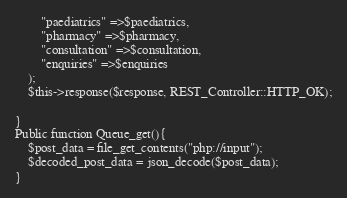Convert code to text. <code><loc_0><loc_0><loc_500><loc_500><_PHP_>        "paediatrics" =>$paediatrics,
        "pharmacy" =>$pharmacy,
        "consultation" =>$consultation,
        "enquiries" =>$enquiries
    );
    $this->response($response, REST_Controller::HTTP_OK);

}
Public function Queue_get(){
    $post_data = file_get_contents("php://input");
    $decoded_post_data = json_decode($post_data);
}</code> 